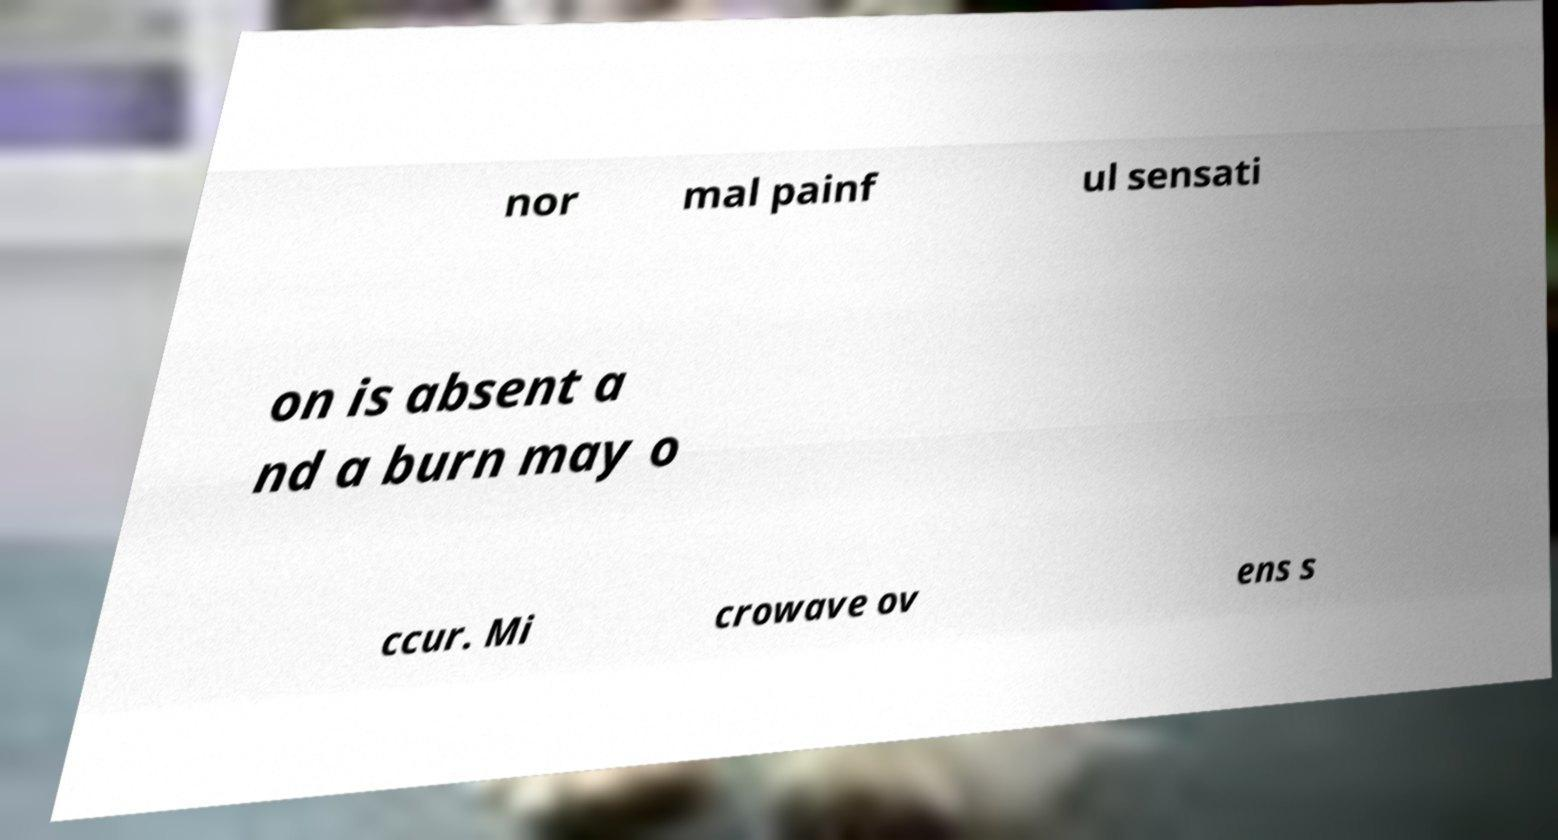For documentation purposes, I need the text within this image transcribed. Could you provide that? nor mal painf ul sensati on is absent a nd a burn may o ccur. Mi crowave ov ens s 